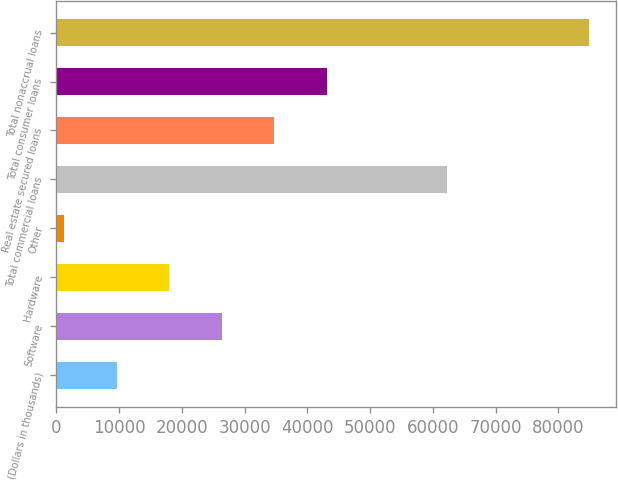<chart> <loc_0><loc_0><loc_500><loc_500><bar_chart><fcel>(Dollars in thousands)<fcel>Software<fcel>Hardware<fcel>Other<fcel>Total commercial loans<fcel>Real estate secured loans<fcel>Total consumer loans<fcel>Total nonaccrual loans<nl><fcel>9625.9<fcel>26357.7<fcel>17991.8<fcel>1260<fcel>62200<fcel>34723.6<fcel>43089.5<fcel>84919<nl></chart> 